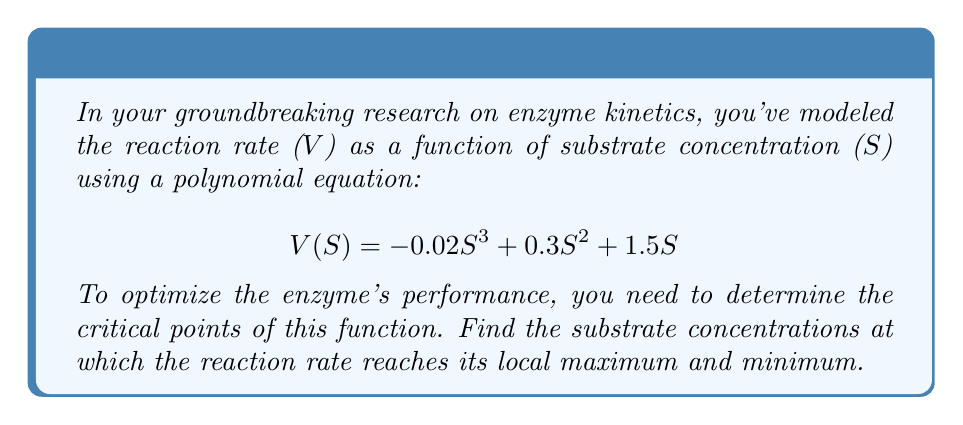What is the answer to this math problem? To find the critical points, we need to follow these steps:

1) First, calculate the derivative of V(S) with respect to S:
   $$V'(S) = -0.06S^2 + 0.6S + 1.5$$

2) Set the derivative equal to zero to find potential critical points:
   $$-0.06S^2 + 0.6S + 1.5 = 0$$

3) This is a quadratic equation. We can solve it using the quadratic formula:
   $$S = \frac{-b \pm \sqrt{b^2 - 4ac}}{2a}$$
   where $a = -0.06$, $b = 0.6$, and $c = 1.5$

4) Substituting these values:
   $$S = \frac{-0.6 \pm \sqrt{0.6^2 - 4(-0.06)(1.5)}}{2(-0.06)}$$

5) Simplifying:
   $$S = \frac{-0.6 \pm \sqrt{0.36 + 0.36}}{-0.12} = \frac{-0.6 \pm \sqrt{0.72}}{-0.12} = \frac{-0.6 \pm 0.8485}{-0.12}$$

6) This gives us two solutions:
   $$S_1 = \frac{-0.6 + 0.8485}{-0.12} \approx 2.07$$
   $$S_2 = \frac{-0.6 - 0.8485}{-0.12} \approx 12.07$$

7) To determine which point is the maximum and which is the minimum, we can use the second derivative test:
   $$V''(S) = -0.12S + 0.6$$

8) Evaluating at $S_1 = 2.07$:
   $$V''(2.07) = -0.12(2.07) + 0.6 \approx 0.3516 > 0$$
   This indicates $S_1$ is a local minimum.

9) Evaluating at $S_2 = 12.07$:
   $$V''(12.07) = -0.12(12.07) + 0.6 \approx -0.8484 < 0$$
   This indicates $S_2$ is a local maximum.
Answer: Local minimum at S ≈ 2.07, local maximum at S ≈ 12.07 